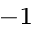<formula> <loc_0><loc_0><loc_500><loc_500>^ { - 1 }</formula> 